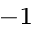<formula> <loc_0><loc_0><loc_500><loc_500>^ { - 1 }</formula> 